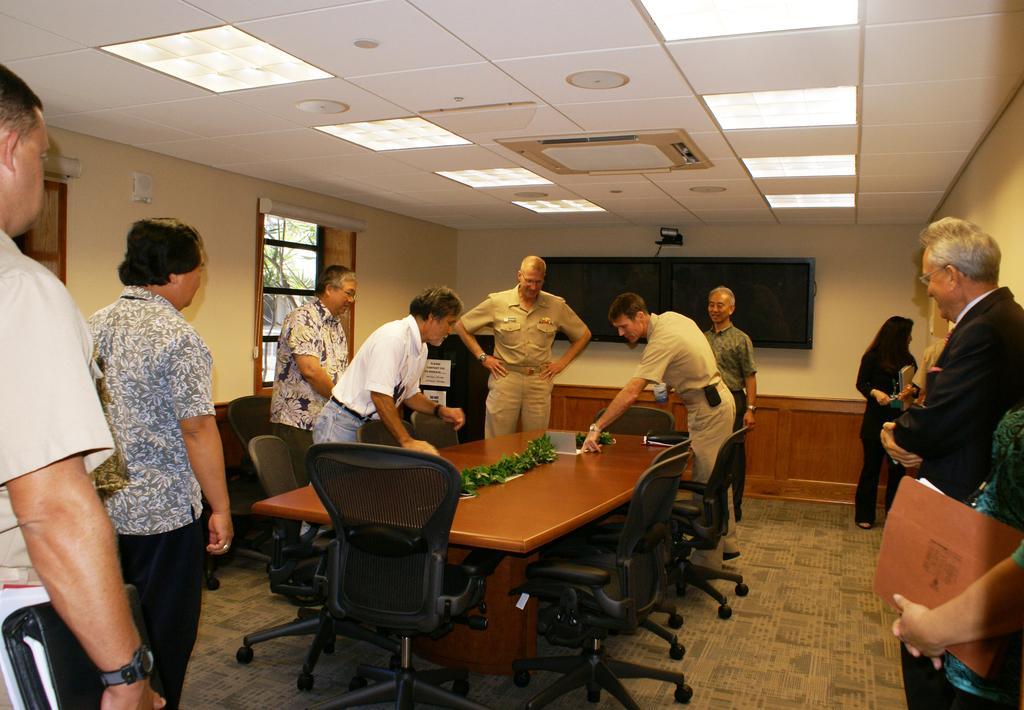How would you summarize this image in a sentence or two? Here we can see a group of people standing here and there and some of them are holding files in their hand and in front of them we can see a table with something on it and there are chairs present and behind them we can see monitors present on the left side we can see a window and we can see trees and there are lights present 